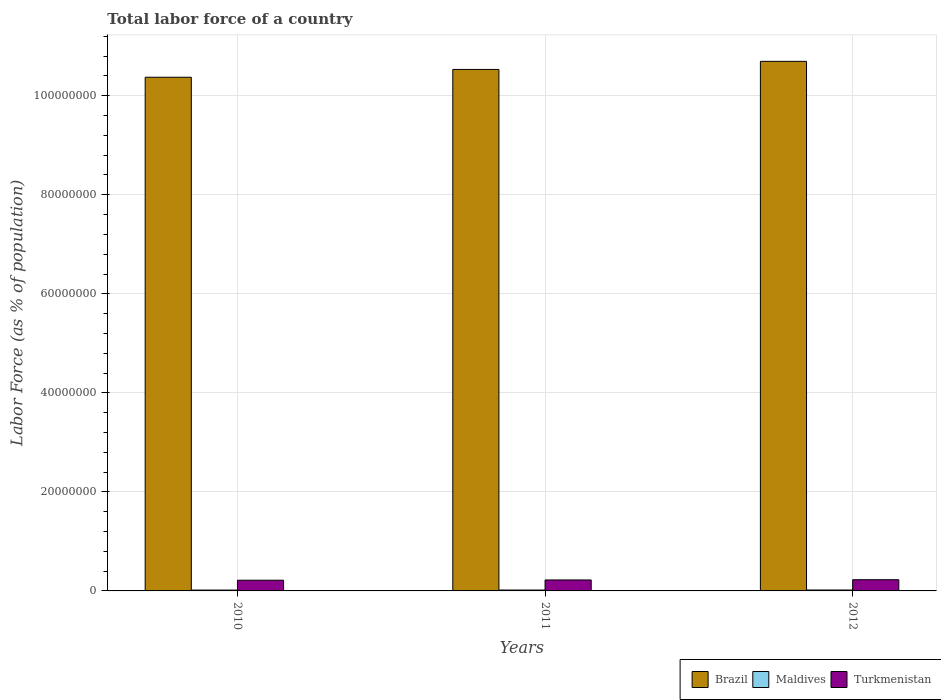How many different coloured bars are there?
Give a very brief answer. 3. How many groups of bars are there?
Offer a terse response. 3. Are the number of bars per tick equal to the number of legend labels?
Keep it short and to the point. Yes. Are the number of bars on each tick of the X-axis equal?
Offer a terse response. Yes. How many bars are there on the 2nd tick from the right?
Give a very brief answer. 3. What is the label of the 3rd group of bars from the left?
Provide a short and direct response. 2012. What is the percentage of labor force in Maldives in 2011?
Your answer should be very brief. 1.79e+05. Across all years, what is the maximum percentage of labor force in Maldives?
Ensure brevity in your answer.  1.85e+05. Across all years, what is the minimum percentage of labor force in Turkmenistan?
Provide a short and direct response. 2.16e+06. What is the total percentage of labor force in Turkmenistan in the graph?
Offer a very short reply. 6.64e+06. What is the difference between the percentage of labor force in Turkmenistan in 2010 and that in 2011?
Your answer should be very brief. -5.27e+04. What is the difference between the percentage of labor force in Turkmenistan in 2011 and the percentage of labor force in Brazil in 2012?
Keep it short and to the point. -1.05e+08. What is the average percentage of labor force in Maldives per year?
Offer a very short reply. 1.78e+05. In the year 2012, what is the difference between the percentage of labor force in Maldives and percentage of labor force in Brazil?
Give a very brief answer. -1.07e+08. What is the ratio of the percentage of labor force in Brazil in 2011 to that in 2012?
Your answer should be compact. 0.98. Is the percentage of labor force in Maldives in 2011 less than that in 2012?
Keep it short and to the point. Yes. What is the difference between the highest and the second highest percentage of labor force in Turkmenistan?
Make the answer very short. 4.67e+04. What is the difference between the highest and the lowest percentage of labor force in Maldives?
Your answer should be compact. 1.26e+04. In how many years, is the percentage of labor force in Maldives greater than the average percentage of labor force in Maldives taken over all years?
Your answer should be compact. 2. Is the sum of the percentage of labor force in Turkmenistan in 2010 and 2012 greater than the maximum percentage of labor force in Maldives across all years?
Offer a terse response. Yes. What does the 3rd bar from the left in 2012 represents?
Give a very brief answer. Turkmenistan. What does the 3rd bar from the right in 2010 represents?
Your answer should be compact. Brazil. How many bars are there?
Keep it short and to the point. 9. Are the values on the major ticks of Y-axis written in scientific E-notation?
Offer a terse response. No. Does the graph contain any zero values?
Keep it short and to the point. No. Does the graph contain grids?
Ensure brevity in your answer.  Yes. How are the legend labels stacked?
Make the answer very short. Horizontal. What is the title of the graph?
Give a very brief answer. Total labor force of a country. Does "Monaco" appear as one of the legend labels in the graph?
Your response must be concise. No. What is the label or title of the X-axis?
Give a very brief answer. Years. What is the label or title of the Y-axis?
Ensure brevity in your answer.  Labor Force (as % of population). What is the Labor Force (as % of population) in Brazil in 2010?
Your answer should be very brief. 1.04e+08. What is the Labor Force (as % of population) of Maldives in 2010?
Give a very brief answer. 1.72e+05. What is the Labor Force (as % of population) in Turkmenistan in 2010?
Keep it short and to the point. 2.16e+06. What is the Labor Force (as % of population) in Brazil in 2011?
Make the answer very short. 1.05e+08. What is the Labor Force (as % of population) of Maldives in 2011?
Make the answer very short. 1.79e+05. What is the Labor Force (as % of population) of Turkmenistan in 2011?
Offer a very short reply. 2.21e+06. What is the Labor Force (as % of population) in Brazil in 2012?
Make the answer very short. 1.07e+08. What is the Labor Force (as % of population) of Maldives in 2012?
Make the answer very short. 1.85e+05. What is the Labor Force (as % of population) in Turkmenistan in 2012?
Ensure brevity in your answer.  2.26e+06. Across all years, what is the maximum Labor Force (as % of population) of Brazil?
Provide a short and direct response. 1.07e+08. Across all years, what is the maximum Labor Force (as % of population) in Maldives?
Offer a terse response. 1.85e+05. Across all years, what is the maximum Labor Force (as % of population) of Turkmenistan?
Provide a short and direct response. 2.26e+06. Across all years, what is the minimum Labor Force (as % of population) of Brazil?
Provide a short and direct response. 1.04e+08. Across all years, what is the minimum Labor Force (as % of population) of Maldives?
Offer a terse response. 1.72e+05. Across all years, what is the minimum Labor Force (as % of population) of Turkmenistan?
Your answer should be very brief. 2.16e+06. What is the total Labor Force (as % of population) in Brazil in the graph?
Offer a terse response. 3.16e+08. What is the total Labor Force (as % of population) in Maldives in the graph?
Give a very brief answer. 5.35e+05. What is the total Labor Force (as % of population) in Turkmenistan in the graph?
Offer a terse response. 6.64e+06. What is the difference between the Labor Force (as % of population) of Brazil in 2010 and that in 2011?
Ensure brevity in your answer.  -1.58e+06. What is the difference between the Labor Force (as % of population) of Maldives in 2010 and that in 2011?
Your response must be concise. -6876. What is the difference between the Labor Force (as % of population) of Turkmenistan in 2010 and that in 2011?
Give a very brief answer. -5.27e+04. What is the difference between the Labor Force (as % of population) of Brazil in 2010 and that in 2012?
Your answer should be very brief. -3.21e+06. What is the difference between the Labor Force (as % of population) of Maldives in 2010 and that in 2012?
Give a very brief answer. -1.26e+04. What is the difference between the Labor Force (as % of population) in Turkmenistan in 2010 and that in 2012?
Ensure brevity in your answer.  -9.94e+04. What is the difference between the Labor Force (as % of population) of Brazil in 2011 and that in 2012?
Provide a short and direct response. -1.63e+06. What is the difference between the Labor Force (as % of population) of Maldives in 2011 and that in 2012?
Give a very brief answer. -5724. What is the difference between the Labor Force (as % of population) in Turkmenistan in 2011 and that in 2012?
Provide a succinct answer. -4.67e+04. What is the difference between the Labor Force (as % of population) of Brazil in 2010 and the Labor Force (as % of population) of Maldives in 2011?
Keep it short and to the point. 1.04e+08. What is the difference between the Labor Force (as % of population) of Brazil in 2010 and the Labor Force (as % of population) of Turkmenistan in 2011?
Ensure brevity in your answer.  1.02e+08. What is the difference between the Labor Force (as % of population) in Maldives in 2010 and the Labor Force (as % of population) in Turkmenistan in 2011?
Your response must be concise. -2.04e+06. What is the difference between the Labor Force (as % of population) in Brazil in 2010 and the Labor Force (as % of population) in Maldives in 2012?
Provide a succinct answer. 1.04e+08. What is the difference between the Labor Force (as % of population) in Brazil in 2010 and the Labor Force (as % of population) in Turkmenistan in 2012?
Your response must be concise. 1.01e+08. What is the difference between the Labor Force (as % of population) of Maldives in 2010 and the Labor Force (as % of population) of Turkmenistan in 2012?
Your response must be concise. -2.09e+06. What is the difference between the Labor Force (as % of population) of Brazil in 2011 and the Labor Force (as % of population) of Maldives in 2012?
Make the answer very short. 1.05e+08. What is the difference between the Labor Force (as % of population) of Brazil in 2011 and the Labor Force (as % of population) of Turkmenistan in 2012?
Offer a very short reply. 1.03e+08. What is the difference between the Labor Force (as % of population) of Maldives in 2011 and the Labor Force (as % of population) of Turkmenistan in 2012?
Ensure brevity in your answer.  -2.08e+06. What is the average Labor Force (as % of population) of Brazil per year?
Provide a succinct answer. 1.05e+08. What is the average Labor Force (as % of population) in Maldives per year?
Your response must be concise. 1.78e+05. What is the average Labor Force (as % of population) in Turkmenistan per year?
Give a very brief answer. 2.21e+06. In the year 2010, what is the difference between the Labor Force (as % of population) in Brazil and Labor Force (as % of population) in Maldives?
Provide a short and direct response. 1.04e+08. In the year 2010, what is the difference between the Labor Force (as % of population) in Brazil and Labor Force (as % of population) in Turkmenistan?
Keep it short and to the point. 1.02e+08. In the year 2010, what is the difference between the Labor Force (as % of population) of Maldives and Labor Force (as % of population) of Turkmenistan?
Give a very brief answer. -1.99e+06. In the year 2011, what is the difference between the Labor Force (as % of population) of Brazil and Labor Force (as % of population) of Maldives?
Offer a very short reply. 1.05e+08. In the year 2011, what is the difference between the Labor Force (as % of population) in Brazil and Labor Force (as % of population) in Turkmenistan?
Your response must be concise. 1.03e+08. In the year 2011, what is the difference between the Labor Force (as % of population) of Maldives and Labor Force (as % of population) of Turkmenistan?
Offer a terse response. -2.04e+06. In the year 2012, what is the difference between the Labor Force (as % of population) in Brazil and Labor Force (as % of population) in Maldives?
Provide a short and direct response. 1.07e+08. In the year 2012, what is the difference between the Labor Force (as % of population) of Brazil and Labor Force (as % of population) of Turkmenistan?
Keep it short and to the point. 1.05e+08. In the year 2012, what is the difference between the Labor Force (as % of population) of Maldives and Labor Force (as % of population) of Turkmenistan?
Give a very brief answer. -2.08e+06. What is the ratio of the Labor Force (as % of population) of Maldives in 2010 to that in 2011?
Ensure brevity in your answer.  0.96. What is the ratio of the Labor Force (as % of population) of Turkmenistan in 2010 to that in 2011?
Offer a very short reply. 0.98. What is the ratio of the Labor Force (as % of population) of Brazil in 2010 to that in 2012?
Offer a very short reply. 0.97. What is the ratio of the Labor Force (as % of population) of Maldives in 2010 to that in 2012?
Your response must be concise. 0.93. What is the ratio of the Labor Force (as % of population) in Turkmenistan in 2010 to that in 2012?
Your answer should be compact. 0.96. What is the ratio of the Labor Force (as % of population) of Brazil in 2011 to that in 2012?
Ensure brevity in your answer.  0.98. What is the ratio of the Labor Force (as % of population) of Maldives in 2011 to that in 2012?
Ensure brevity in your answer.  0.97. What is the ratio of the Labor Force (as % of population) in Turkmenistan in 2011 to that in 2012?
Provide a succinct answer. 0.98. What is the difference between the highest and the second highest Labor Force (as % of population) in Brazil?
Ensure brevity in your answer.  1.63e+06. What is the difference between the highest and the second highest Labor Force (as % of population) in Maldives?
Keep it short and to the point. 5724. What is the difference between the highest and the second highest Labor Force (as % of population) of Turkmenistan?
Your response must be concise. 4.67e+04. What is the difference between the highest and the lowest Labor Force (as % of population) of Brazil?
Your response must be concise. 3.21e+06. What is the difference between the highest and the lowest Labor Force (as % of population) in Maldives?
Offer a terse response. 1.26e+04. What is the difference between the highest and the lowest Labor Force (as % of population) of Turkmenistan?
Your response must be concise. 9.94e+04. 